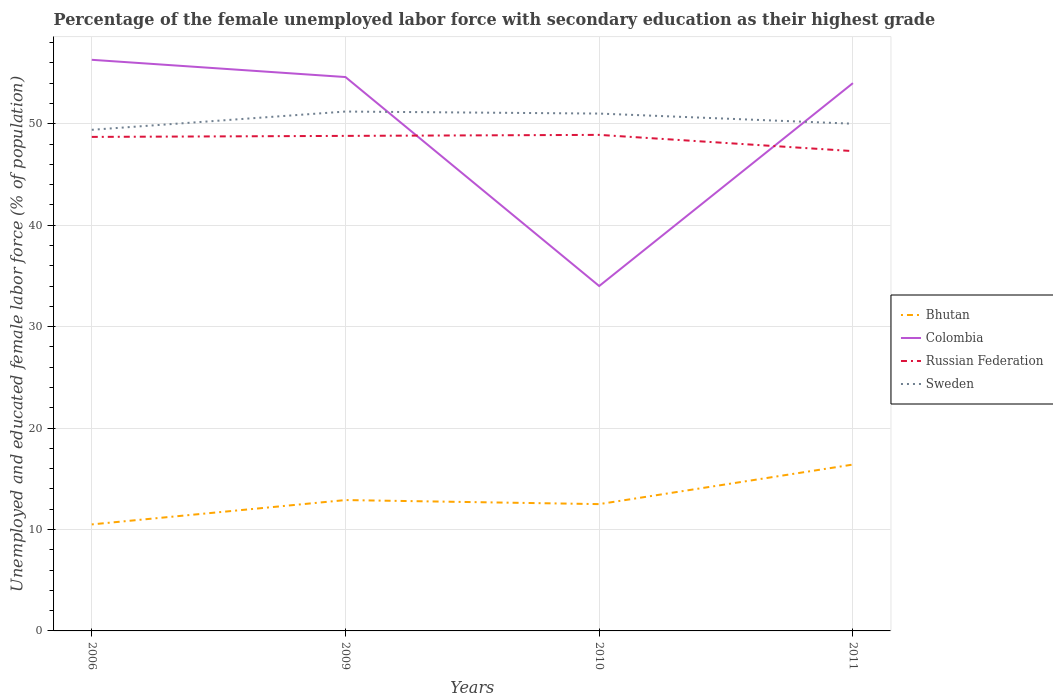How many different coloured lines are there?
Make the answer very short. 4. Does the line corresponding to Sweden intersect with the line corresponding to Russian Federation?
Offer a very short reply. No. Across all years, what is the maximum percentage of the unemployed female labor force with secondary education in Colombia?
Provide a succinct answer. 34. What is the total percentage of the unemployed female labor force with secondary education in Sweden in the graph?
Keep it short and to the point. -0.6. What is the difference between the highest and the second highest percentage of the unemployed female labor force with secondary education in Russian Federation?
Offer a very short reply. 1.6. What is the difference between the highest and the lowest percentage of the unemployed female labor force with secondary education in Sweden?
Make the answer very short. 2. How many years are there in the graph?
Offer a terse response. 4. What is the difference between two consecutive major ticks on the Y-axis?
Provide a succinct answer. 10. How many legend labels are there?
Offer a terse response. 4. What is the title of the graph?
Offer a very short reply. Percentage of the female unemployed labor force with secondary education as their highest grade. What is the label or title of the Y-axis?
Keep it short and to the point. Unemployed and educated female labor force (% of population). What is the Unemployed and educated female labor force (% of population) of Colombia in 2006?
Provide a short and direct response. 56.3. What is the Unemployed and educated female labor force (% of population) of Russian Federation in 2006?
Your answer should be very brief. 48.7. What is the Unemployed and educated female labor force (% of population) in Sweden in 2006?
Provide a succinct answer. 49.4. What is the Unemployed and educated female labor force (% of population) of Bhutan in 2009?
Keep it short and to the point. 12.9. What is the Unemployed and educated female labor force (% of population) of Colombia in 2009?
Your answer should be compact. 54.6. What is the Unemployed and educated female labor force (% of population) of Russian Federation in 2009?
Your response must be concise. 48.8. What is the Unemployed and educated female labor force (% of population) of Sweden in 2009?
Offer a very short reply. 51.2. What is the Unemployed and educated female labor force (% of population) in Colombia in 2010?
Give a very brief answer. 34. What is the Unemployed and educated female labor force (% of population) of Russian Federation in 2010?
Your response must be concise. 48.9. What is the Unemployed and educated female labor force (% of population) in Bhutan in 2011?
Offer a terse response. 16.4. What is the Unemployed and educated female labor force (% of population) in Colombia in 2011?
Your answer should be compact. 54. What is the Unemployed and educated female labor force (% of population) of Russian Federation in 2011?
Your answer should be compact. 47.3. What is the Unemployed and educated female labor force (% of population) of Sweden in 2011?
Offer a terse response. 50. Across all years, what is the maximum Unemployed and educated female labor force (% of population) of Bhutan?
Give a very brief answer. 16.4. Across all years, what is the maximum Unemployed and educated female labor force (% of population) in Colombia?
Ensure brevity in your answer.  56.3. Across all years, what is the maximum Unemployed and educated female labor force (% of population) in Russian Federation?
Your answer should be very brief. 48.9. Across all years, what is the maximum Unemployed and educated female labor force (% of population) of Sweden?
Offer a very short reply. 51.2. Across all years, what is the minimum Unemployed and educated female labor force (% of population) in Russian Federation?
Your response must be concise. 47.3. Across all years, what is the minimum Unemployed and educated female labor force (% of population) of Sweden?
Make the answer very short. 49.4. What is the total Unemployed and educated female labor force (% of population) in Bhutan in the graph?
Provide a succinct answer. 52.3. What is the total Unemployed and educated female labor force (% of population) in Colombia in the graph?
Keep it short and to the point. 198.9. What is the total Unemployed and educated female labor force (% of population) of Russian Federation in the graph?
Your answer should be very brief. 193.7. What is the total Unemployed and educated female labor force (% of population) in Sweden in the graph?
Give a very brief answer. 201.6. What is the difference between the Unemployed and educated female labor force (% of population) of Bhutan in 2006 and that in 2009?
Provide a succinct answer. -2.4. What is the difference between the Unemployed and educated female labor force (% of population) of Colombia in 2006 and that in 2009?
Your answer should be compact. 1.7. What is the difference between the Unemployed and educated female labor force (% of population) of Colombia in 2006 and that in 2010?
Your answer should be very brief. 22.3. What is the difference between the Unemployed and educated female labor force (% of population) of Russian Federation in 2006 and that in 2010?
Keep it short and to the point. -0.2. What is the difference between the Unemployed and educated female labor force (% of population) in Colombia in 2006 and that in 2011?
Provide a succinct answer. 2.3. What is the difference between the Unemployed and educated female labor force (% of population) in Russian Federation in 2006 and that in 2011?
Provide a short and direct response. 1.4. What is the difference between the Unemployed and educated female labor force (% of population) in Colombia in 2009 and that in 2010?
Your response must be concise. 20.6. What is the difference between the Unemployed and educated female labor force (% of population) in Sweden in 2009 and that in 2010?
Provide a succinct answer. 0.2. What is the difference between the Unemployed and educated female labor force (% of population) of Russian Federation in 2009 and that in 2011?
Offer a terse response. 1.5. What is the difference between the Unemployed and educated female labor force (% of population) of Sweden in 2009 and that in 2011?
Make the answer very short. 1.2. What is the difference between the Unemployed and educated female labor force (% of population) of Russian Federation in 2010 and that in 2011?
Keep it short and to the point. 1.6. What is the difference between the Unemployed and educated female labor force (% of population) of Bhutan in 2006 and the Unemployed and educated female labor force (% of population) of Colombia in 2009?
Your response must be concise. -44.1. What is the difference between the Unemployed and educated female labor force (% of population) in Bhutan in 2006 and the Unemployed and educated female labor force (% of population) in Russian Federation in 2009?
Provide a succinct answer. -38.3. What is the difference between the Unemployed and educated female labor force (% of population) of Bhutan in 2006 and the Unemployed and educated female labor force (% of population) of Sweden in 2009?
Your response must be concise. -40.7. What is the difference between the Unemployed and educated female labor force (% of population) in Russian Federation in 2006 and the Unemployed and educated female labor force (% of population) in Sweden in 2009?
Give a very brief answer. -2.5. What is the difference between the Unemployed and educated female labor force (% of population) of Bhutan in 2006 and the Unemployed and educated female labor force (% of population) of Colombia in 2010?
Offer a terse response. -23.5. What is the difference between the Unemployed and educated female labor force (% of population) of Bhutan in 2006 and the Unemployed and educated female labor force (% of population) of Russian Federation in 2010?
Give a very brief answer. -38.4. What is the difference between the Unemployed and educated female labor force (% of population) in Bhutan in 2006 and the Unemployed and educated female labor force (% of population) in Sweden in 2010?
Your response must be concise. -40.5. What is the difference between the Unemployed and educated female labor force (% of population) of Bhutan in 2006 and the Unemployed and educated female labor force (% of population) of Colombia in 2011?
Make the answer very short. -43.5. What is the difference between the Unemployed and educated female labor force (% of population) of Bhutan in 2006 and the Unemployed and educated female labor force (% of population) of Russian Federation in 2011?
Offer a very short reply. -36.8. What is the difference between the Unemployed and educated female labor force (% of population) in Bhutan in 2006 and the Unemployed and educated female labor force (% of population) in Sweden in 2011?
Your answer should be compact. -39.5. What is the difference between the Unemployed and educated female labor force (% of population) in Colombia in 2006 and the Unemployed and educated female labor force (% of population) in Sweden in 2011?
Give a very brief answer. 6.3. What is the difference between the Unemployed and educated female labor force (% of population) in Bhutan in 2009 and the Unemployed and educated female labor force (% of population) in Colombia in 2010?
Your answer should be compact. -21.1. What is the difference between the Unemployed and educated female labor force (% of population) in Bhutan in 2009 and the Unemployed and educated female labor force (% of population) in Russian Federation in 2010?
Provide a short and direct response. -36. What is the difference between the Unemployed and educated female labor force (% of population) in Bhutan in 2009 and the Unemployed and educated female labor force (% of population) in Sweden in 2010?
Your answer should be very brief. -38.1. What is the difference between the Unemployed and educated female labor force (% of population) of Colombia in 2009 and the Unemployed and educated female labor force (% of population) of Sweden in 2010?
Keep it short and to the point. 3.6. What is the difference between the Unemployed and educated female labor force (% of population) in Russian Federation in 2009 and the Unemployed and educated female labor force (% of population) in Sweden in 2010?
Keep it short and to the point. -2.2. What is the difference between the Unemployed and educated female labor force (% of population) of Bhutan in 2009 and the Unemployed and educated female labor force (% of population) of Colombia in 2011?
Provide a succinct answer. -41.1. What is the difference between the Unemployed and educated female labor force (% of population) of Bhutan in 2009 and the Unemployed and educated female labor force (% of population) of Russian Federation in 2011?
Ensure brevity in your answer.  -34.4. What is the difference between the Unemployed and educated female labor force (% of population) in Bhutan in 2009 and the Unemployed and educated female labor force (% of population) in Sweden in 2011?
Your answer should be compact. -37.1. What is the difference between the Unemployed and educated female labor force (% of population) of Colombia in 2009 and the Unemployed and educated female labor force (% of population) of Russian Federation in 2011?
Provide a succinct answer. 7.3. What is the difference between the Unemployed and educated female labor force (% of population) in Colombia in 2009 and the Unemployed and educated female labor force (% of population) in Sweden in 2011?
Give a very brief answer. 4.6. What is the difference between the Unemployed and educated female labor force (% of population) of Russian Federation in 2009 and the Unemployed and educated female labor force (% of population) of Sweden in 2011?
Ensure brevity in your answer.  -1.2. What is the difference between the Unemployed and educated female labor force (% of population) of Bhutan in 2010 and the Unemployed and educated female labor force (% of population) of Colombia in 2011?
Your answer should be very brief. -41.5. What is the difference between the Unemployed and educated female labor force (% of population) of Bhutan in 2010 and the Unemployed and educated female labor force (% of population) of Russian Federation in 2011?
Your answer should be very brief. -34.8. What is the difference between the Unemployed and educated female labor force (% of population) of Bhutan in 2010 and the Unemployed and educated female labor force (% of population) of Sweden in 2011?
Give a very brief answer. -37.5. What is the difference between the Unemployed and educated female labor force (% of population) in Colombia in 2010 and the Unemployed and educated female labor force (% of population) in Russian Federation in 2011?
Keep it short and to the point. -13.3. What is the difference between the Unemployed and educated female labor force (% of population) of Russian Federation in 2010 and the Unemployed and educated female labor force (% of population) of Sweden in 2011?
Your answer should be compact. -1.1. What is the average Unemployed and educated female labor force (% of population) in Bhutan per year?
Provide a short and direct response. 13.07. What is the average Unemployed and educated female labor force (% of population) of Colombia per year?
Offer a terse response. 49.73. What is the average Unemployed and educated female labor force (% of population) in Russian Federation per year?
Offer a very short reply. 48.42. What is the average Unemployed and educated female labor force (% of population) of Sweden per year?
Ensure brevity in your answer.  50.4. In the year 2006, what is the difference between the Unemployed and educated female labor force (% of population) in Bhutan and Unemployed and educated female labor force (% of population) in Colombia?
Ensure brevity in your answer.  -45.8. In the year 2006, what is the difference between the Unemployed and educated female labor force (% of population) in Bhutan and Unemployed and educated female labor force (% of population) in Russian Federation?
Your answer should be compact. -38.2. In the year 2006, what is the difference between the Unemployed and educated female labor force (% of population) in Bhutan and Unemployed and educated female labor force (% of population) in Sweden?
Provide a succinct answer. -38.9. In the year 2006, what is the difference between the Unemployed and educated female labor force (% of population) in Colombia and Unemployed and educated female labor force (% of population) in Russian Federation?
Provide a succinct answer. 7.6. In the year 2006, what is the difference between the Unemployed and educated female labor force (% of population) of Russian Federation and Unemployed and educated female labor force (% of population) of Sweden?
Give a very brief answer. -0.7. In the year 2009, what is the difference between the Unemployed and educated female labor force (% of population) in Bhutan and Unemployed and educated female labor force (% of population) in Colombia?
Keep it short and to the point. -41.7. In the year 2009, what is the difference between the Unemployed and educated female labor force (% of population) in Bhutan and Unemployed and educated female labor force (% of population) in Russian Federation?
Ensure brevity in your answer.  -35.9. In the year 2009, what is the difference between the Unemployed and educated female labor force (% of population) in Bhutan and Unemployed and educated female labor force (% of population) in Sweden?
Your answer should be very brief. -38.3. In the year 2009, what is the difference between the Unemployed and educated female labor force (% of population) of Colombia and Unemployed and educated female labor force (% of population) of Russian Federation?
Provide a succinct answer. 5.8. In the year 2009, what is the difference between the Unemployed and educated female labor force (% of population) in Colombia and Unemployed and educated female labor force (% of population) in Sweden?
Provide a succinct answer. 3.4. In the year 2010, what is the difference between the Unemployed and educated female labor force (% of population) of Bhutan and Unemployed and educated female labor force (% of population) of Colombia?
Offer a very short reply. -21.5. In the year 2010, what is the difference between the Unemployed and educated female labor force (% of population) of Bhutan and Unemployed and educated female labor force (% of population) of Russian Federation?
Provide a succinct answer. -36.4. In the year 2010, what is the difference between the Unemployed and educated female labor force (% of population) of Bhutan and Unemployed and educated female labor force (% of population) of Sweden?
Provide a short and direct response. -38.5. In the year 2010, what is the difference between the Unemployed and educated female labor force (% of population) in Colombia and Unemployed and educated female labor force (% of population) in Russian Federation?
Your response must be concise. -14.9. In the year 2010, what is the difference between the Unemployed and educated female labor force (% of population) of Colombia and Unemployed and educated female labor force (% of population) of Sweden?
Provide a short and direct response. -17. In the year 2010, what is the difference between the Unemployed and educated female labor force (% of population) in Russian Federation and Unemployed and educated female labor force (% of population) in Sweden?
Give a very brief answer. -2.1. In the year 2011, what is the difference between the Unemployed and educated female labor force (% of population) of Bhutan and Unemployed and educated female labor force (% of population) of Colombia?
Give a very brief answer. -37.6. In the year 2011, what is the difference between the Unemployed and educated female labor force (% of population) in Bhutan and Unemployed and educated female labor force (% of population) in Russian Federation?
Your answer should be compact. -30.9. In the year 2011, what is the difference between the Unemployed and educated female labor force (% of population) in Bhutan and Unemployed and educated female labor force (% of population) in Sweden?
Offer a terse response. -33.6. In the year 2011, what is the difference between the Unemployed and educated female labor force (% of population) in Colombia and Unemployed and educated female labor force (% of population) in Sweden?
Offer a terse response. 4. In the year 2011, what is the difference between the Unemployed and educated female labor force (% of population) of Russian Federation and Unemployed and educated female labor force (% of population) of Sweden?
Give a very brief answer. -2.7. What is the ratio of the Unemployed and educated female labor force (% of population) in Bhutan in 2006 to that in 2009?
Your response must be concise. 0.81. What is the ratio of the Unemployed and educated female labor force (% of population) of Colombia in 2006 to that in 2009?
Provide a succinct answer. 1.03. What is the ratio of the Unemployed and educated female labor force (% of population) of Russian Federation in 2006 to that in 2009?
Ensure brevity in your answer.  1. What is the ratio of the Unemployed and educated female labor force (% of population) in Sweden in 2006 to that in 2009?
Provide a short and direct response. 0.96. What is the ratio of the Unemployed and educated female labor force (% of population) in Bhutan in 2006 to that in 2010?
Provide a short and direct response. 0.84. What is the ratio of the Unemployed and educated female labor force (% of population) in Colombia in 2006 to that in 2010?
Keep it short and to the point. 1.66. What is the ratio of the Unemployed and educated female labor force (% of population) in Russian Federation in 2006 to that in 2010?
Offer a very short reply. 1. What is the ratio of the Unemployed and educated female labor force (% of population) in Sweden in 2006 to that in 2010?
Provide a succinct answer. 0.97. What is the ratio of the Unemployed and educated female labor force (% of population) in Bhutan in 2006 to that in 2011?
Give a very brief answer. 0.64. What is the ratio of the Unemployed and educated female labor force (% of population) in Colombia in 2006 to that in 2011?
Provide a succinct answer. 1.04. What is the ratio of the Unemployed and educated female labor force (% of population) of Russian Federation in 2006 to that in 2011?
Offer a very short reply. 1.03. What is the ratio of the Unemployed and educated female labor force (% of population) in Sweden in 2006 to that in 2011?
Your answer should be very brief. 0.99. What is the ratio of the Unemployed and educated female labor force (% of population) in Bhutan in 2009 to that in 2010?
Give a very brief answer. 1.03. What is the ratio of the Unemployed and educated female labor force (% of population) in Colombia in 2009 to that in 2010?
Keep it short and to the point. 1.61. What is the ratio of the Unemployed and educated female labor force (% of population) in Bhutan in 2009 to that in 2011?
Provide a succinct answer. 0.79. What is the ratio of the Unemployed and educated female labor force (% of population) of Colombia in 2009 to that in 2011?
Offer a very short reply. 1.01. What is the ratio of the Unemployed and educated female labor force (% of population) of Russian Federation in 2009 to that in 2011?
Give a very brief answer. 1.03. What is the ratio of the Unemployed and educated female labor force (% of population) in Sweden in 2009 to that in 2011?
Offer a very short reply. 1.02. What is the ratio of the Unemployed and educated female labor force (% of population) in Bhutan in 2010 to that in 2011?
Ensure brevity in your answer.  0.76. What is the ratio of the Unemployed and educated female labor force (% of population) in Colombia in 2010 to that in 2011?
Your response must be concise. 0.63. What is the ratio of the Unemployed and educated female labor force (% of population) in Russian Federation in 2010 to that in 2011?
Provide a short and direct response. 1.03. What is the ratio of the Unemployed and educated female labor force (% of population) of Sweden in 2010 to that in 2011?
Provide a short and direct response. 1.02. What is the difference between the highest and the second highest Unemployed and educated female labor force (% of population) in Colombia?
Ensure brevity in your answer.  1.7. What is the difference between the highest and the lowest Unemployed and educated female labor force (% of population) in Bhutan?
Ensure brevity in your answer.  5.9. What is the difference between the highest and the lowest Unemployed and educated female labor force (% of population) of Colombia?
Your answer should be very brief. 22.3. What is the difference between the highest and the lowest Unemployed and educated female labor force (% of population) of Sweden?
Ensure brevity in your answer.  1.8. 